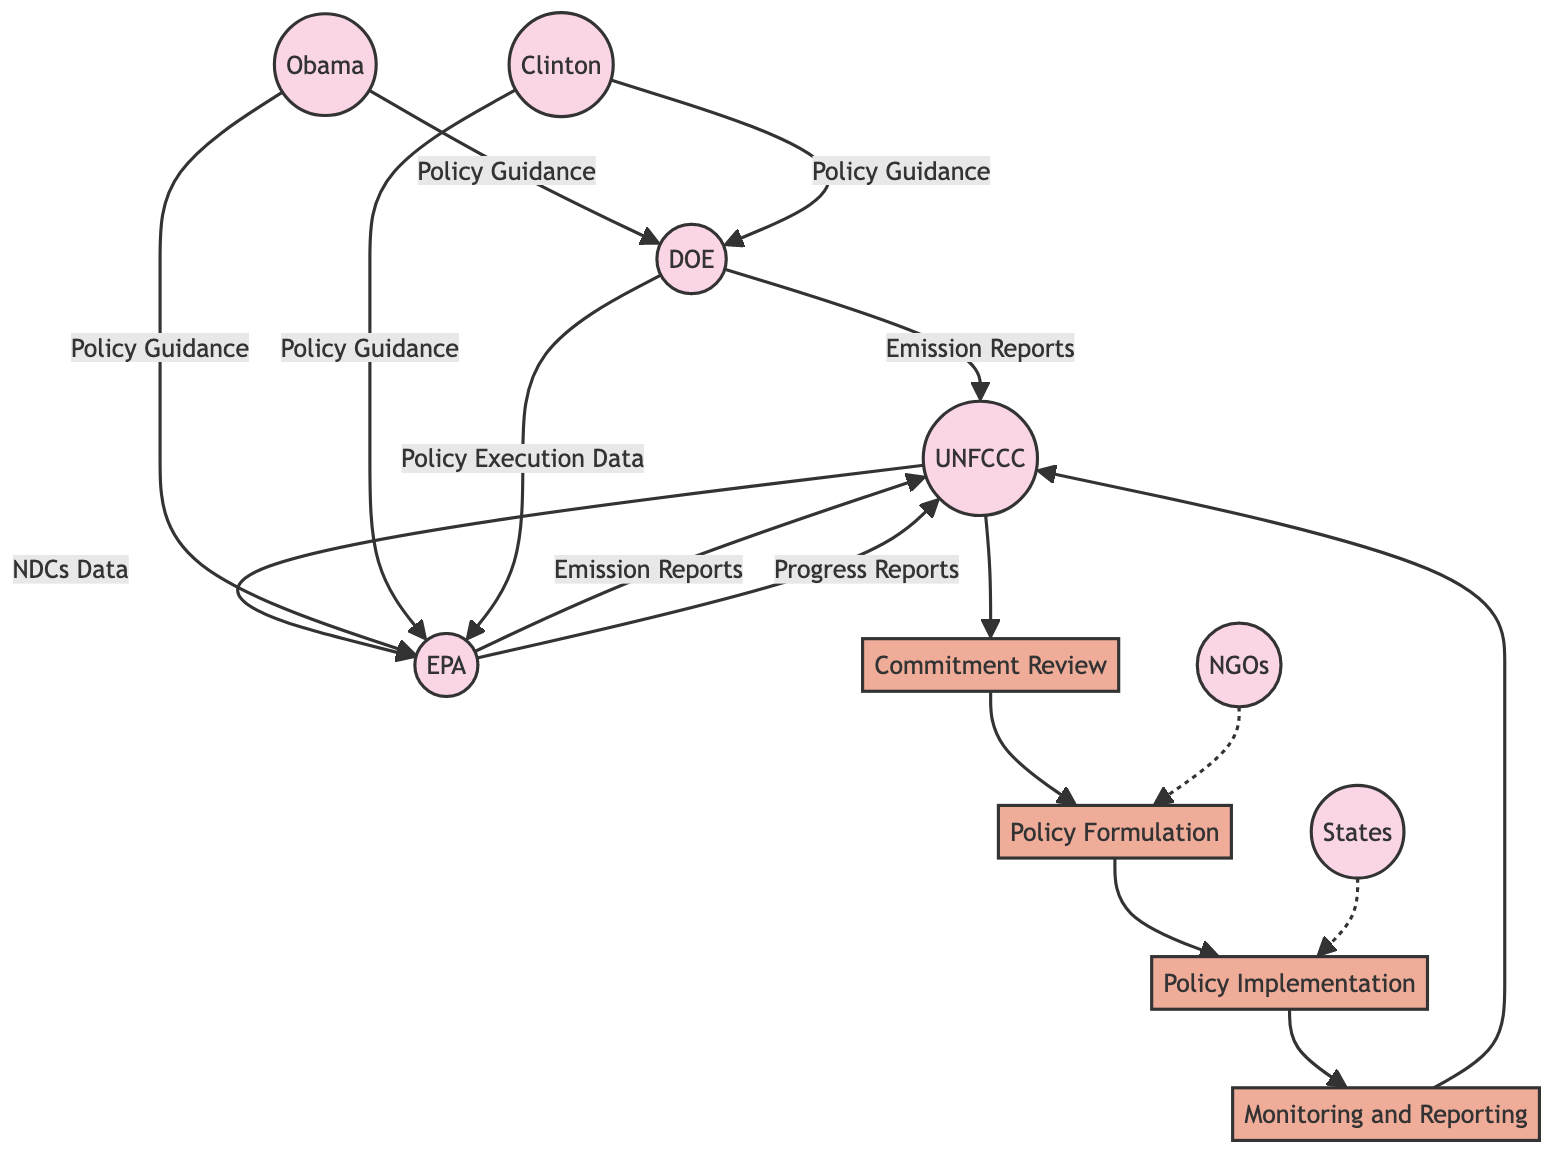What are the entities involved in the diagram? The diagram contains several entities, including UNFCCC, EPA, DOE, Obama, Clinton, NGOs, and States. These entities represent various participants in the climate policy workflow.
Answer: UNFCCC, EPA, DOE, Obama, Clinton, NGOs, States How many processes are illustrated in the diagram? The diagram shows four specific processes: Commitment Review, Policy Formulation, Policy Implementation, and Monitoring and Reporting. Each process represents a stage in the workflow of climate policy implementation.
Answer: 4 Who provides policy guidance in the diagram? According to the diagram, the policy guidance is provided by Obama and Clinton. They influence the processes by offering their guidance to EPA and DOE.
Answer: Obama, Clinton What type of data flow occurs from EPA to UNFCCC? The diagram specifies that EPA sends Emission Reports to UNFCCC, which highlights the reporting aspect of the climate policy implementation.
Answer: Emission Reports Which organizations receive NDCs Data? The NDCs Data flows from UNFCCC to EPA, indicating that the Environmental Protection Agency is the recipient of this data regarding national commitments.
Answer: EPA What is the sequence of processes from Commitment Review to Monitoring Reporting? The sequence begins with Commitment Review, then moves to Policy Formulation, followed by Policy Implementation, and concludes with Monitoring Reporting. This order outlines the logical flow of actions taken in response to the Paris Agreement commitments.
Answer: Commitment Review, Policy Formulation, Policy Implementation, Monitoring Reporting How do NGOs relate to the Policy Formulation process? The diagram illustrates that NGOs have a dotted line connection to Policy Formulation, suggesting their influence or involvement in shaping climate policies, albeit less direct compared to other entities.
Answer: Influence What is the final output of the Monitoring Reporting process? The output from the Monitoring Reporting process is directed back to UNFCCC, where the progress and emissions data are reported, satisfying the monitoring requirements set by international agreements.
Answer: UNFCCC What is the source of the Policy Execution Data? The source of Policy Execution Data is identified as DOE, which indicates that the Department of Energy plays a role in executing the policies and contributing data to the EPA.
Answer: DOE 